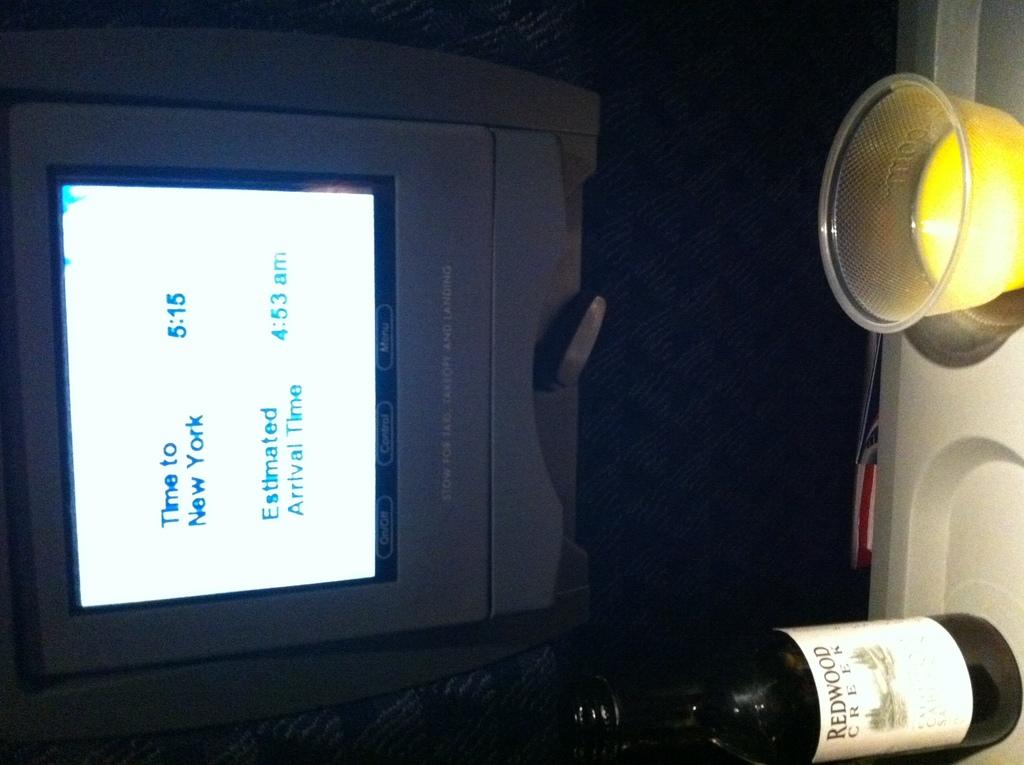When will the flight arrive in new york?
Provide a short and direct response. 4:53am. 